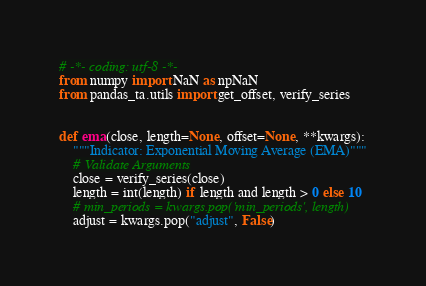<code> <loc_0><loc_0><loc_500><loc_500><_Python_># -*- coding: utf-8 -*-
from numpy import NaN as npNaN
from pandas_ta.utils import get_offset, verify_series


def ema(close, length=None, offset=None, **kwargs):
    """Indicator: Exponential Moving Average (EMA)"""
    # Validate Arguments
    close = verify_series(close)
    length = int(length) if length and length > 0 else 10
    # min_periods = kwargs.pop('min_periods', length)
    adjust = kwargs.pop("adjust", False)</code> 